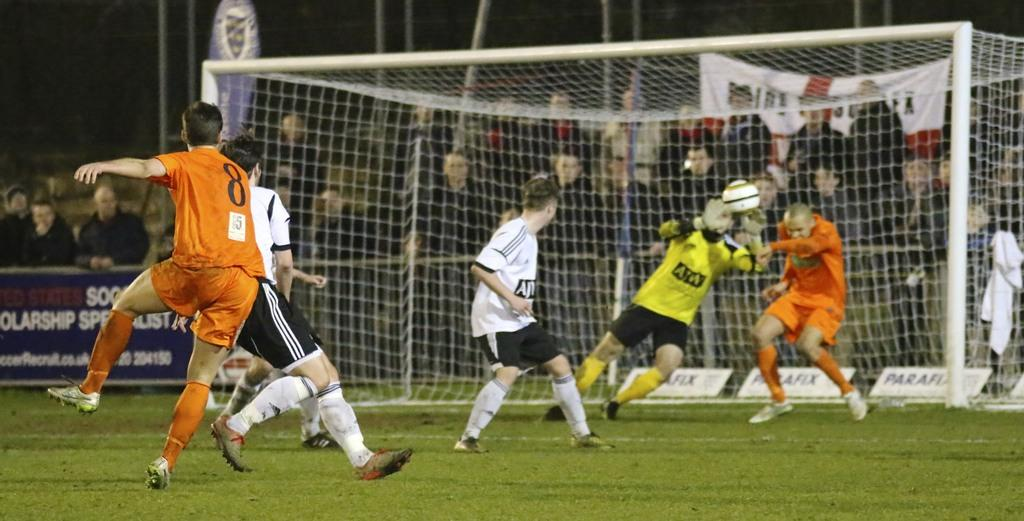<image>
Offer a succinct explanation of the picture presented. A soccer player in an orange shirt with the number 8 on it. 